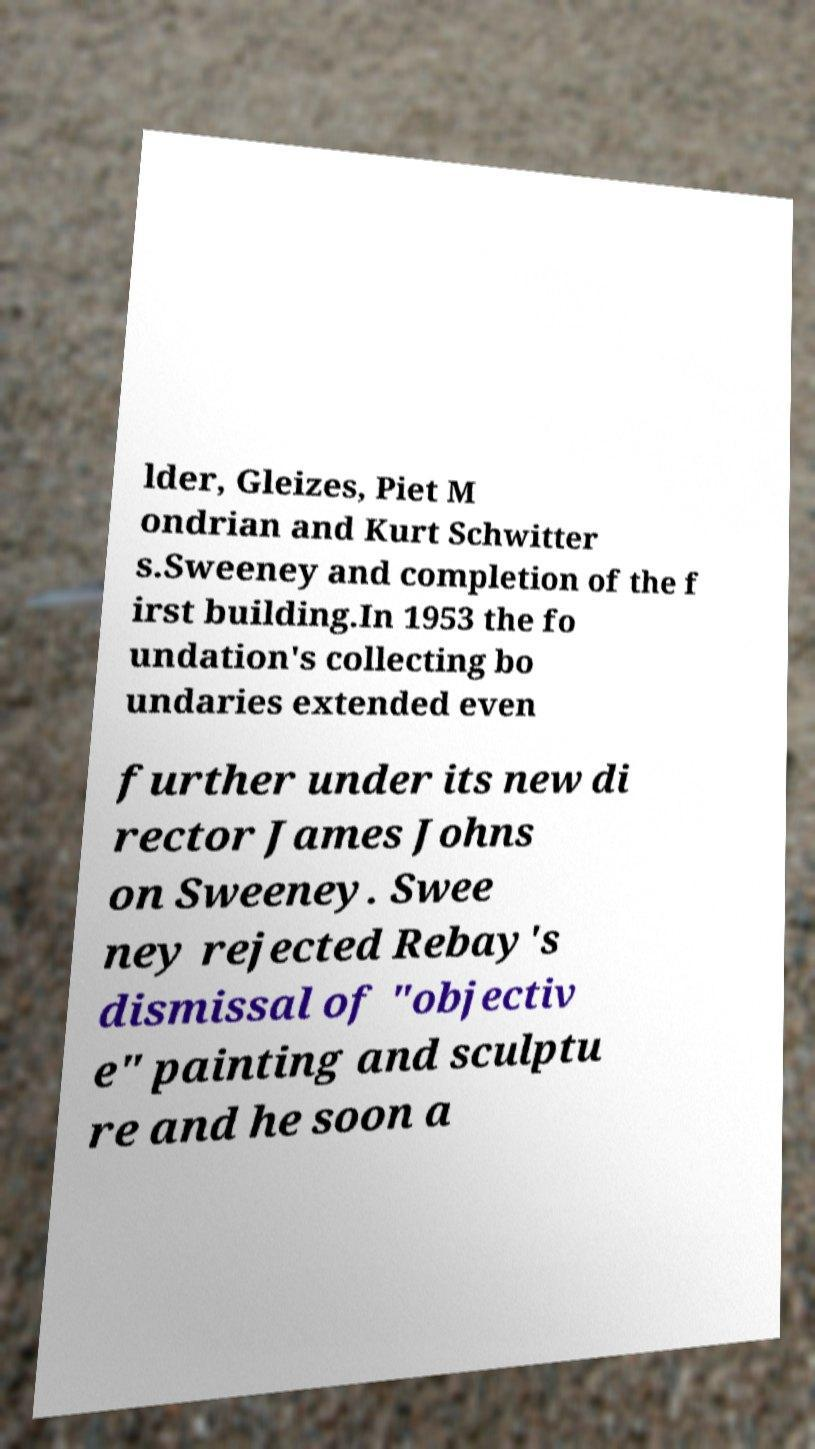Can you read and provide the text displayed in the image?This photo seems to have some interesting text. Can you extract and type it out for me? lder, Gleizes, Piet M ondrian and Kurt Schwitter s.Sweeney and completion of the f irst building.In 1953 the fo undation's collecting bo undaries extended even further under its new di rector James Johns on Sweeney. Swee ney rejected Rebay's dismissal of "objectiv e" painting and sculptu re and he soon a 